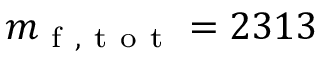Convert formula to latex. <formula><loc_0><loc_0><loc_500><loc_500>m _ { f , t o t } = 2 3 1 3</formula> 